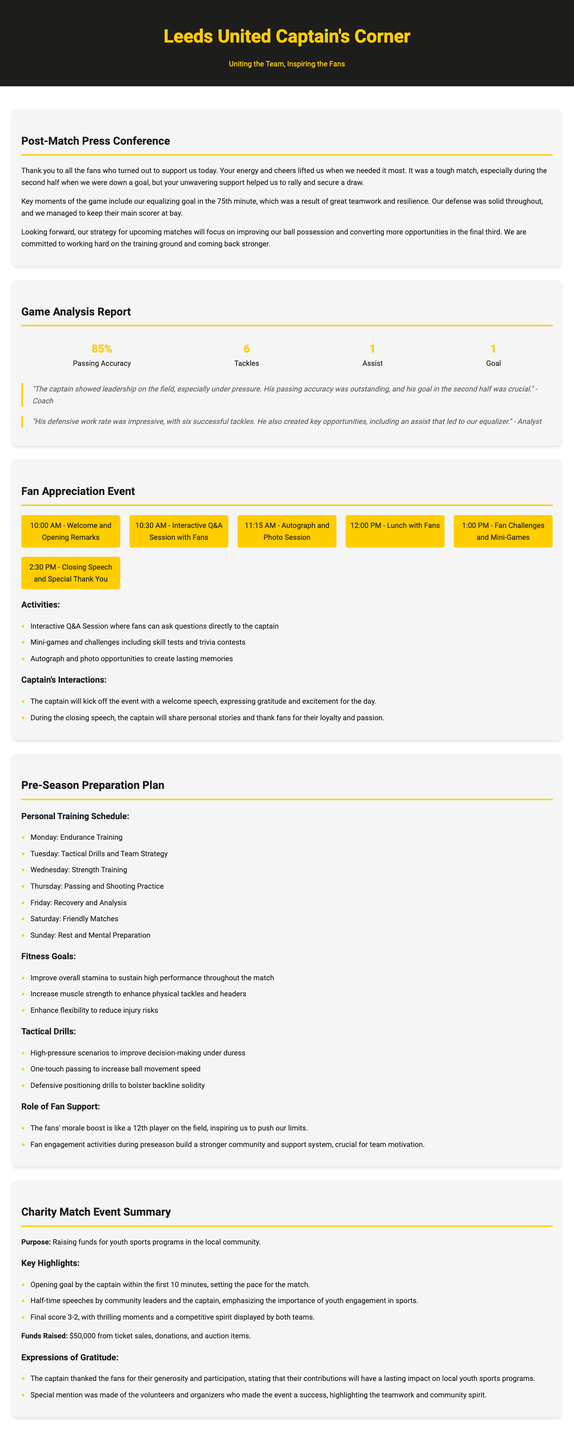What was the match result? The match resulted in a draw, as mentioned in the post-match press conference.
Answer: Draw What time does the fan appreciation event start? The event starts at 10:00 AM, as listed in the schedule.
Answer: 10:00 AM How many tackles did the captain make during the game? The captain made 6 tackles, as stated in the game analysis report.
Answer: 6 What is the purpose of the charity match? The purpose is to raise funds for youth sports programs in the local community.
Answer: Raising funds for youth sports programs What was the captain's passing accuracy during the match? The captain's passing accuracy was 85%, as indicated in the game analysis report.
Answer: 85% What is one of the captain's fitness goals? One fitness goal is to improve overall stamina to sustain high performance throughout the match.
Answer: Improve overall stamina What will the captain address during the closing speech at the event? The captain will share personal stories and thank fans for their loyalty and passion.
Answer: Thank fans for their loyalty and passion How much money was raised from the charity match? The fundraising total from the charity match was $50,000.
Answer: $50,000 What activity starts at 10:30 AM during the fan appreciation event? An interactive Q&A session with fans is scheduled to start at 10:30 AM.
Answer: Interactive Q&A Session 